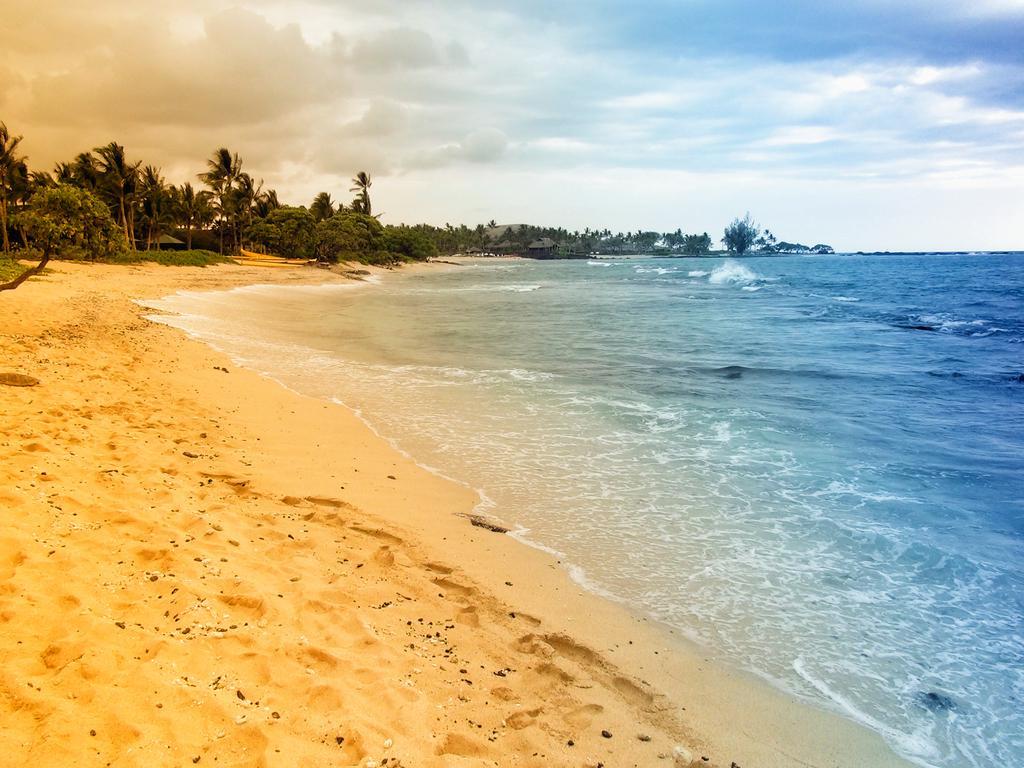Describe this image in one or two sentences. In this image we can see the sea, mountains, two houses, some sand, some objects on the ground, some trees, bushes, plants and grass on the ground. At the top there is the cloudy sky. 